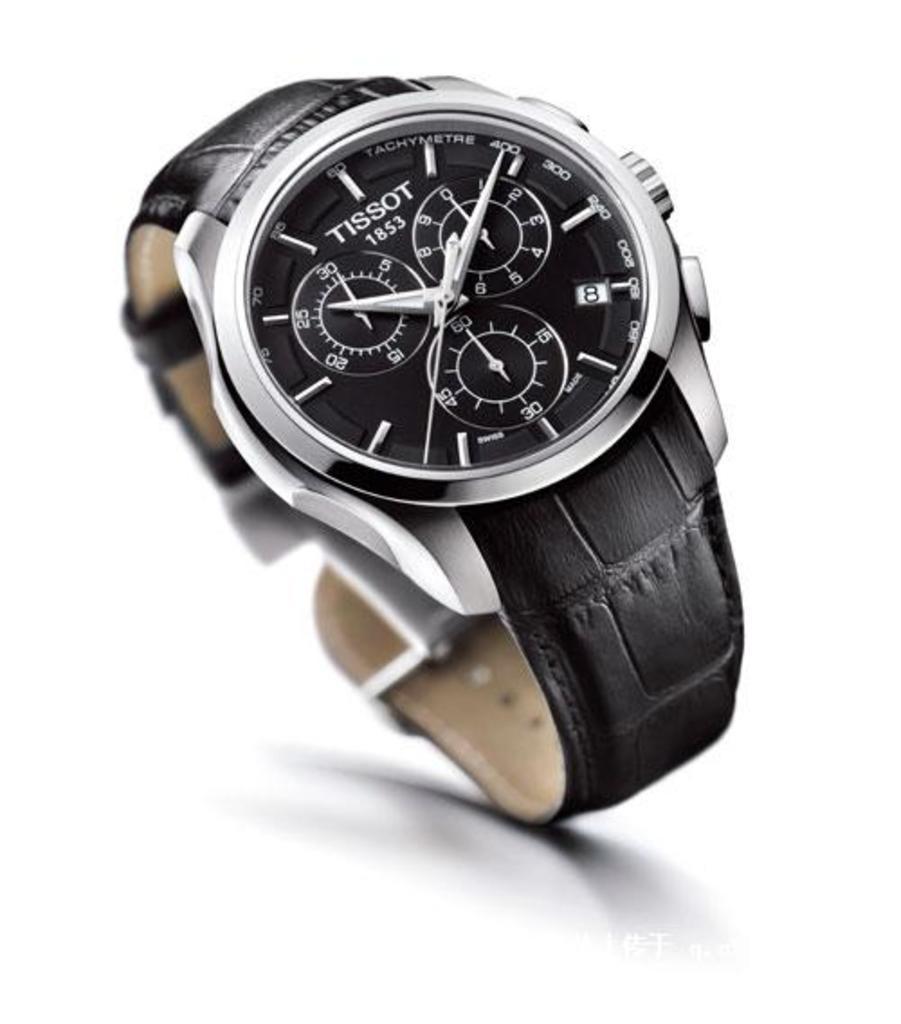In one or two sentences, can you explain what this image depicts? In the center of the image there is a black color watch. 